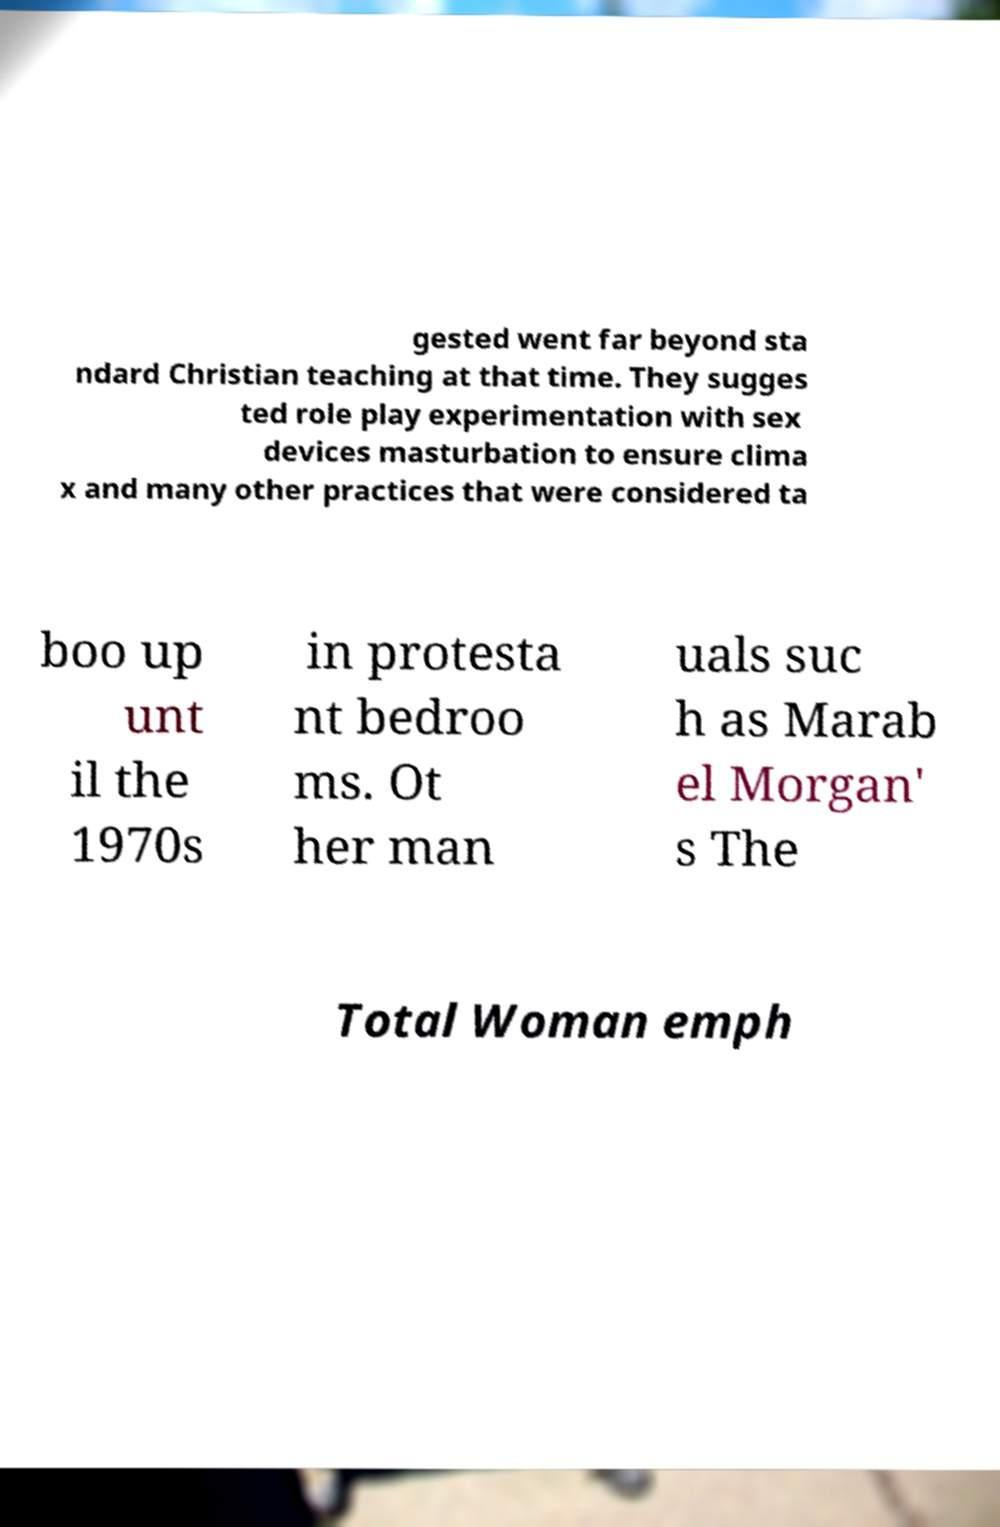Could you assist in decoding the text presented in this image and type it out clearly? gested went far beyond sta ndard Christian teaching at that time. They sugges ted role play experimentation with sex devices masturbation to ensure clima x and many other practices that were considered ta boo up unt il the 1970s in protesta nt bedroo ms. Ot her man uals suc h as Marab el Morgan' s The Total Woman emph 